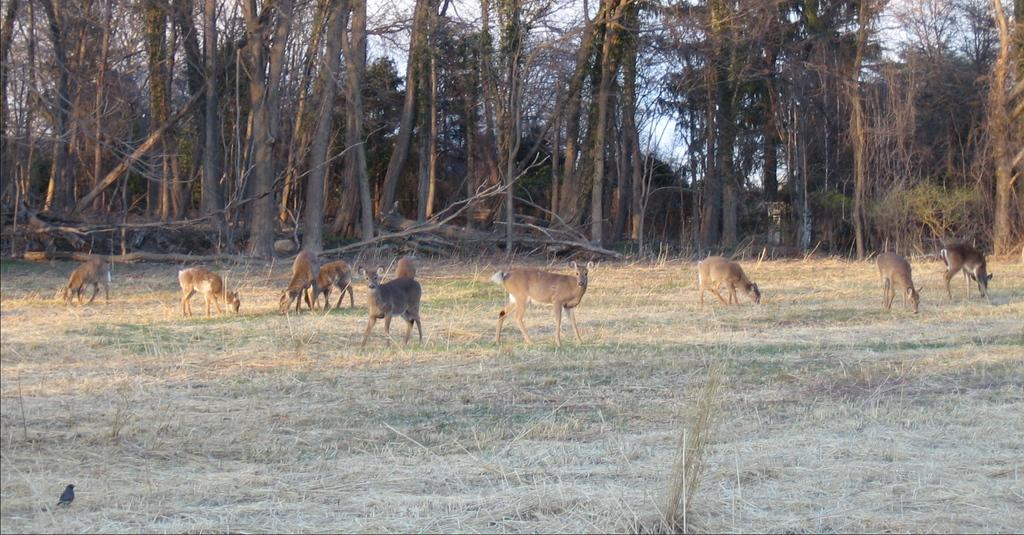What type of environment is depicted in the image? The image shows animals on a grassy land. Where is the grassy land located in the image? The grassy land is in the middle of the image. What can be seen in the background of the image? There are trees in the background of the image. What book is the animal reading in the image? There is no book present in the image; it features animals on a grassy land with trees in the background. 